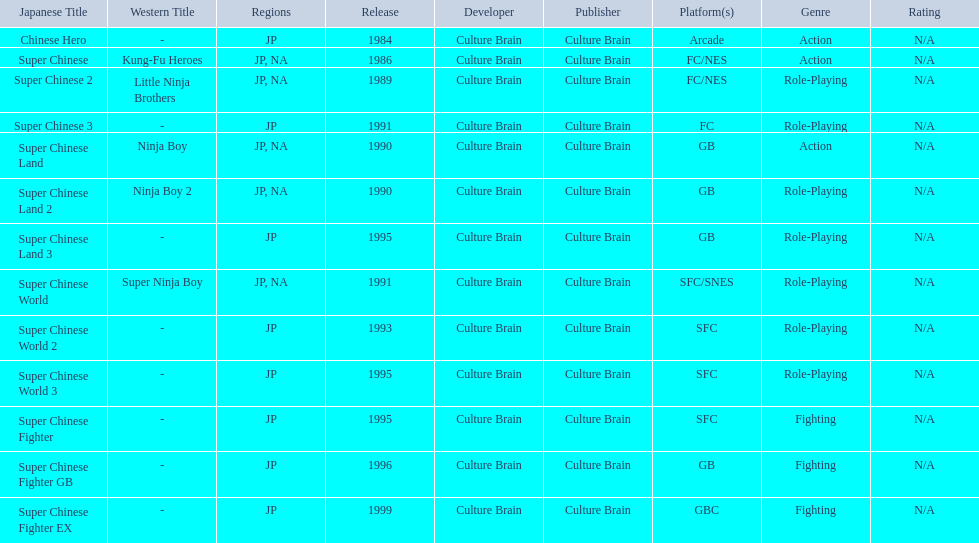Super ninja world was released in what countries? JP, NA. What was the original name for this title? Super Chinese World. 